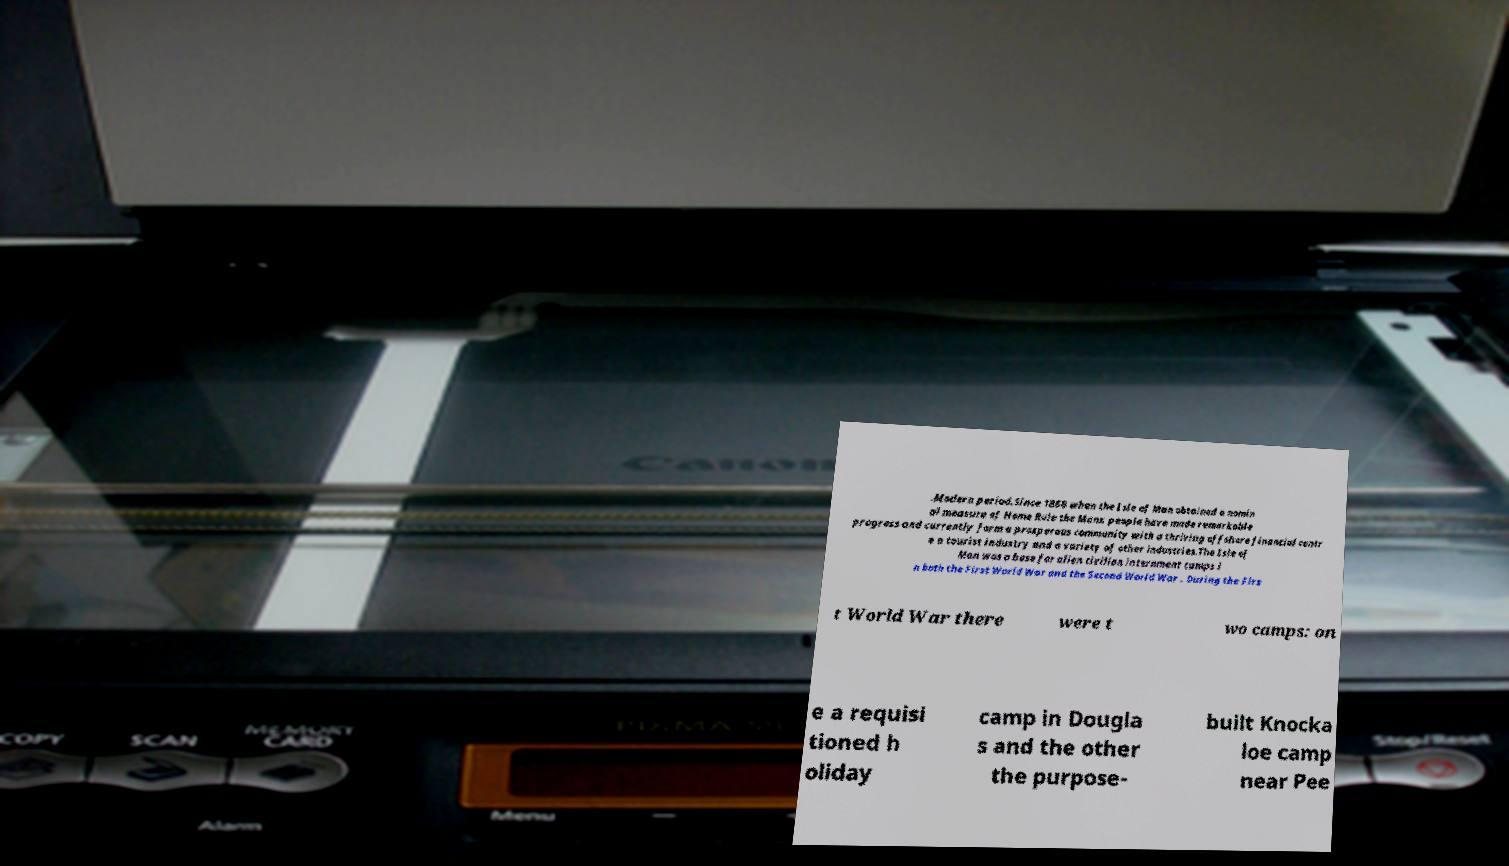Please identify and transcribe the text found in this image. .Modern period.Since 1866 when the Isle of Man obtained a nomin al measure of Home Rule the Manx people have made remarkable progress and currently form a prosperous community with a thriving offshore financial centr e a tourist industry and a variety of other industries.The Isle of Man was a base for alien civilian internment camps i n both the First World War and the Second World War . During the Firs t World War there were t wo camps: on e a requisi tioned h oliday camp in Dougla s and the other the purpose- built Knocka loe camp near Pee 